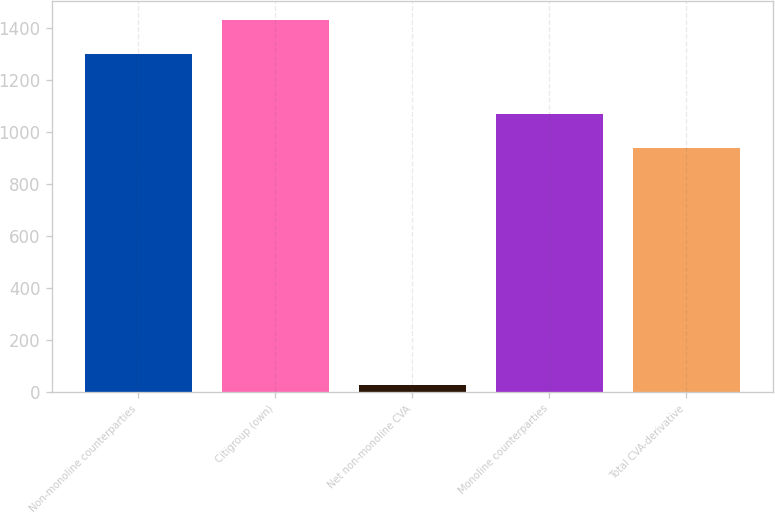Convert chart. <chart><loc_0><loc_0><loc_500><loc_500><bar_chart><fcel>Non-monoline counterparties<fcel>Citigroup (own)<fcel>Net non-monoline CVA<fcel>Monoline counterparties<fcel>Total CVA-derivative<nl><fcel>1301<fcel>1431.1<fcel>28<fcel>1069.1<fcel>939<nl></chart> 